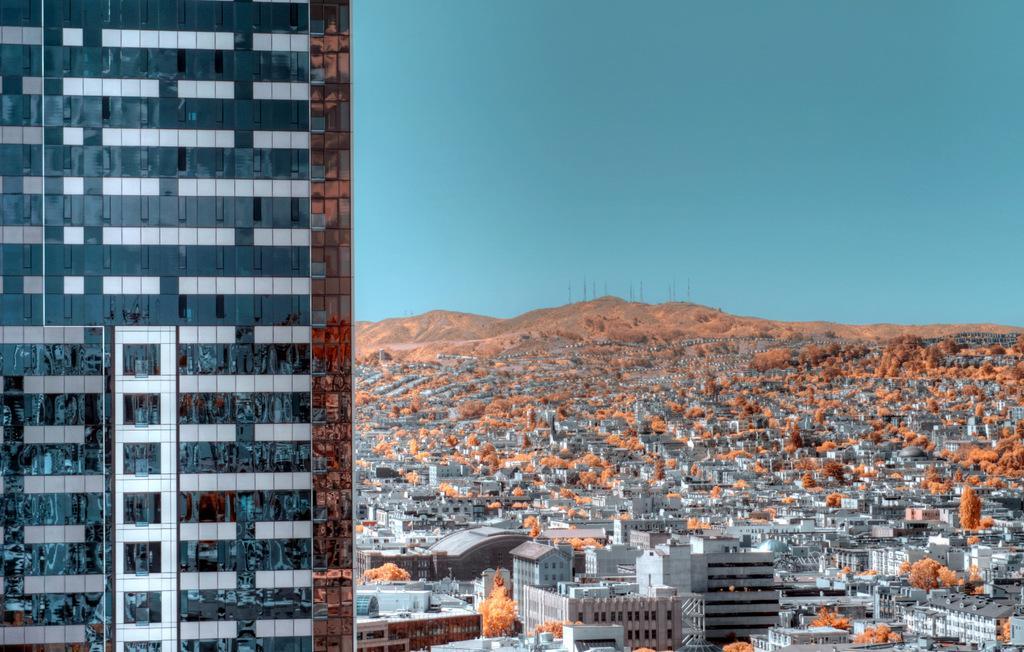Please provide a concise description of this image. On the left side, there is a glass building. In the background, there are buildings and trees on the ground, there are mountains and there is blue sky. 